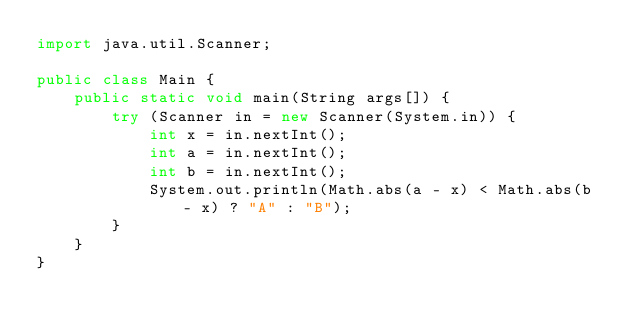<code> <loc_0><loc_0><loc_500><loc_500><_Java_>import java.util.Scanner;

public class Main {
    public static void main(String args[]) {
        try (Scanner in = new Scanner(System.in)) {
            int x = in.nextInt();
            int a = in.nextInt();
            int b = in.nextInt();
            System.out.println(Math.abs(a - x) < Math.abs(b - x) ? "A" : "B");
        }
    }
}
</code> 